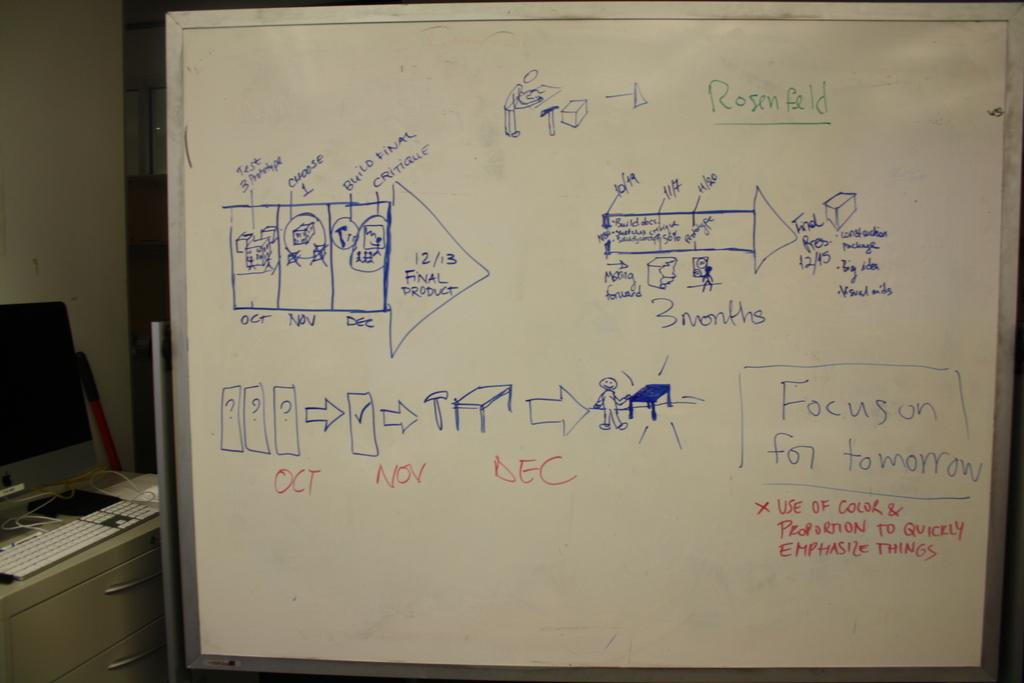<image>
Write a terse but informative summary of the picture. A whiteboard with the message Focus on For Tomorrow written on it. 